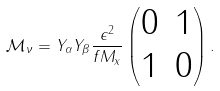<formula> <loc_0><loc_0><loc_500><loc_500>\mathcal { M } _ { \nu } = Y _ { \alpha } Y _ { \beta } \frac { \epsilon ^ { 2 } } { f M _ { x } } \left ( \begin{matrix} 0 & 1 \\ 1 & 0 \end{matrix} \right ) .</formula> 